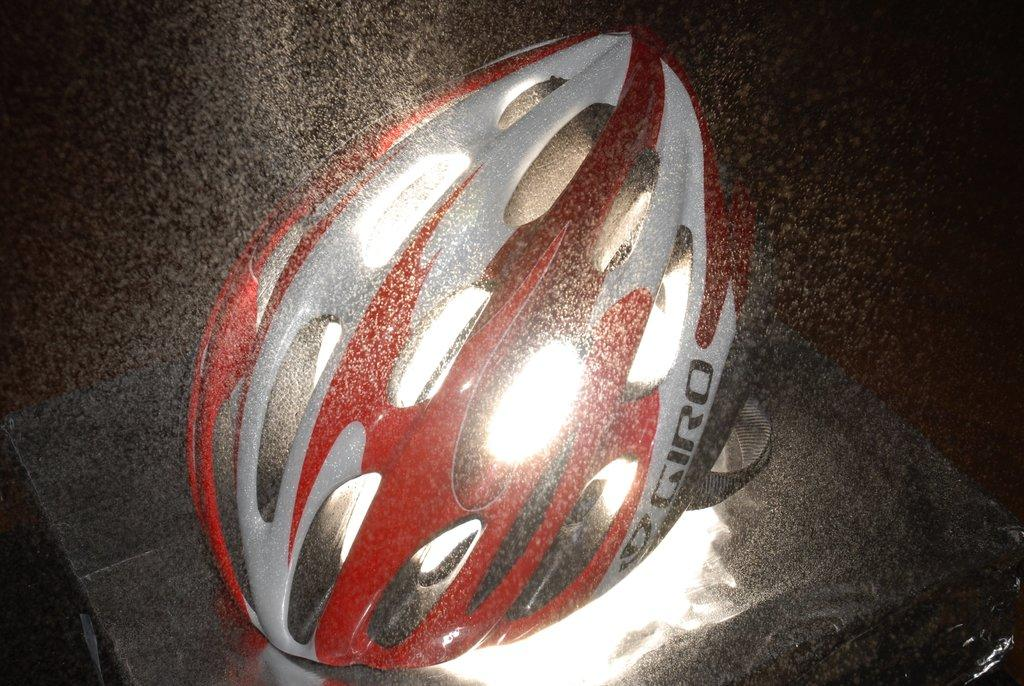What object is the main focus of the image? There is a helmet in the image. What colors are used to design the helmet? The helmet is red and white in color. What can be seen in the background of the image? The background of the image is black. What type of discussion is taking place in the image? There is no discussion taking place in the image; it only features a helmet. What experience can be gained from wearing the helmet in the image? The image does not depict anyone wearing the helmet, so it is impossible to determine any potential experience gained from wearing it. 